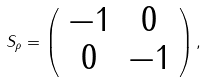Convert formula to latex. <formula><loc_0><loc_0><loc_500><loc_500>S _ { \rho } = \left ( \begin{array} { c c } - 1 & 0 \\ 0 & - 1 \end{array} \right ) ,</formula> 